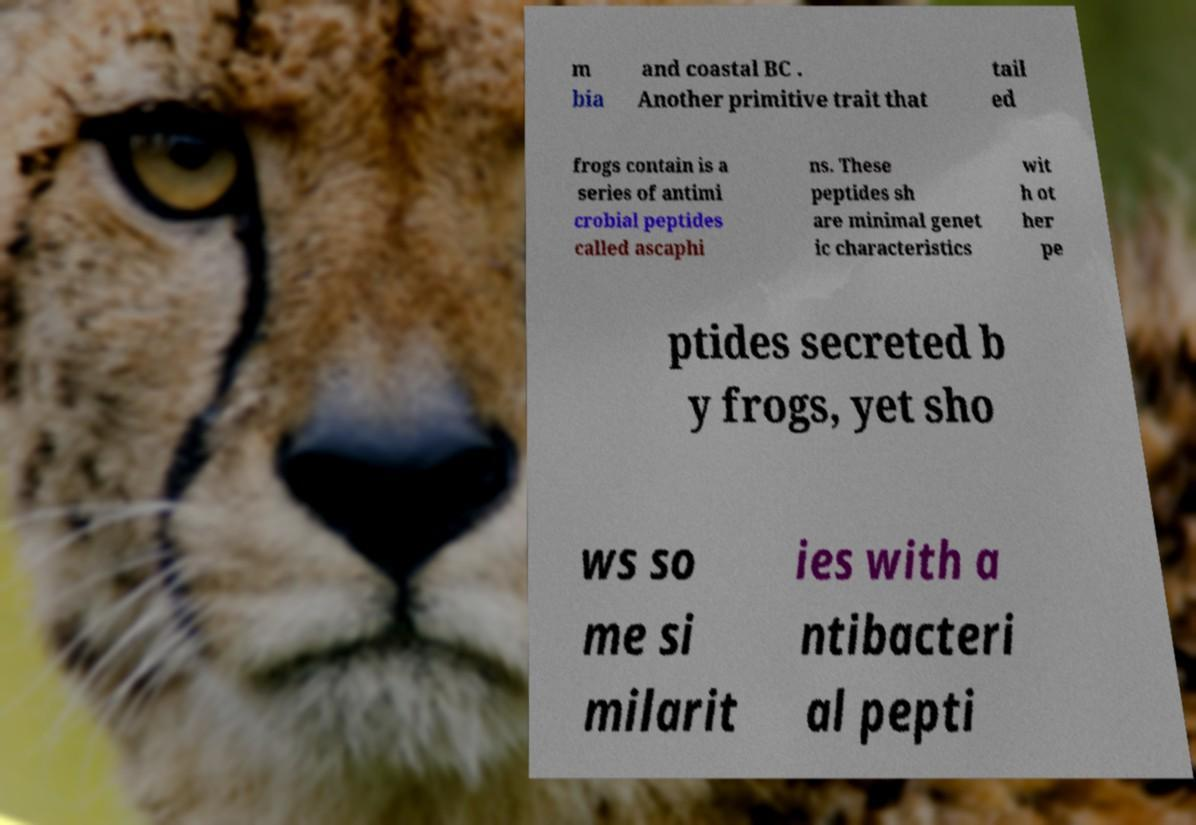Can you accurately transcribe the text from the provided image for me? m bia and coastal BC . Another primitive trait that tail ed frogs contain is a series of antimi crobial peptides called ascaphi ns. These peptides sh are minimal genet ic characteristics wit h ot her pe ptides secreted b y frogs, yet sho ws so me si milarit ies with a ntibacteri al pepti 